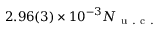<formula> <loc_0><loc_0><loc_500><loc_500>2 . 9 6 ( 3 ) \times 1 0 ^ { - 3 } N _ { u . c . }</formula> 